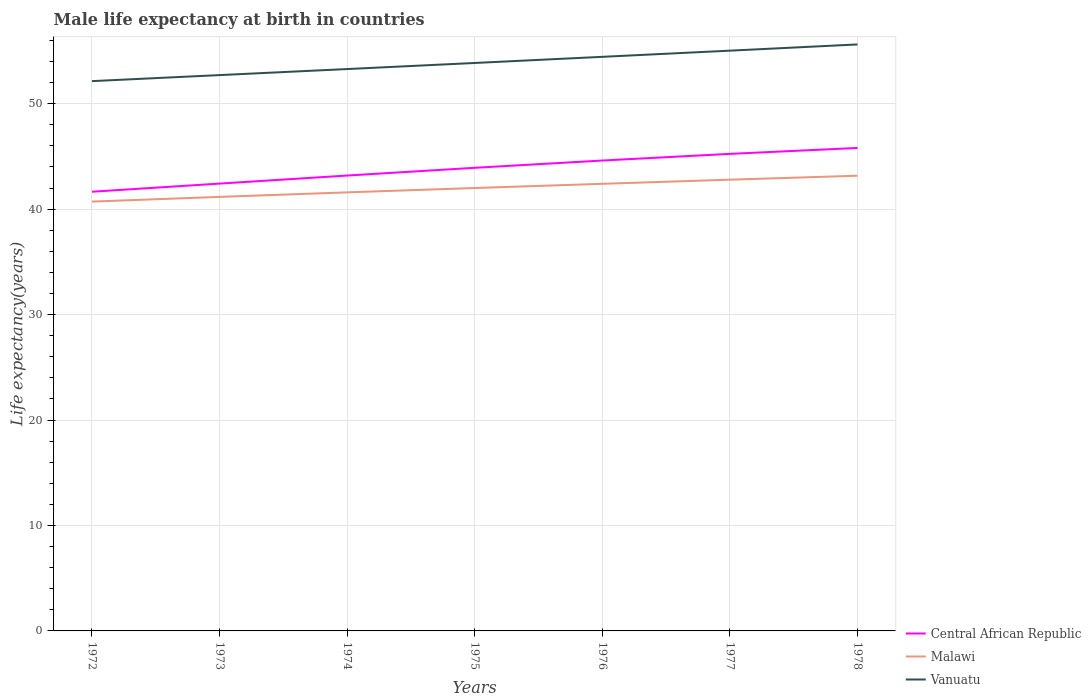How many different coloured lines are there?
Offer a very short reply. 3. Across all years, what is the maximum male life expectancy at birth in Central African Republic?
Offer a terse response. 41.65. What is the total male life expectancy at birth in Vanuatu in the graph?
Give a very brief answer. -0.58. What is the difference between the highest and the second highest male life expectancy at birth in Malawi?
Provide a succinct answer. 2.45. Is the male life expectancy at birth in Vanuatu strictly greater than the male life expectancy at birth in Central African Republic over the years?
Keep it short and to the point. No. How many lines are there?
Make the answer very short. 3. What is the difference between two consecutive major ticks on the Y-axis?
Give a very brief answer. 10. Are the values on the major ticks of Y-axis written in scientific E-notation?
Provide a short and direct response. No. Does the graph contain any zero values?
Your response must be concise. No. What is the title of the graph?
Offer a very short reply. Male life expectancy at birth in countries. Does "Morocco" appear as one of the legend labels in the graph?
Your response must be concise. No. What is the label or title of the Y-axis?
Ensure brevity in your answer.  Life expectancy(years). What is the Life expectancy(years) of Central African Republic in 1972?
Provide a short and direct response. 41.65. What is the Life expectancy(years) of Malawi in 1972?
Ensure brevity in your answer.  40.71. What is the Life expectancy(years) in Vanuatu in 1972?
Offer a very short reply. 52.14. What is the Life expectancy(years) of Central African Republic in 1973?
Give a very brief answer. 42.42. What is the Life expectancy(years) of Malawi in 1973?
Offer a terse response. 41.16. What is the Life expectancy(years) in Vanuatu in 1973?
Provide a succinct answer. 52.71. What is the Life expectancy(years) in Central African Republic in 1974?
Provide a succinct answer. 43.18. What is the Life expectancy(years) of Malawi in 1974?
Provide a succinct answer. 41.59. What is the Life expectancy(years) in Vanuatu in 1974?
Give a very brief answer. 53.28. What is the Life expectancy(years) in Central African Republic in 1975?
Provide a short and direct response. 43.92. What is the Life expectancy(years) in Malawi in 1975?
Your answer should be very brief. 42. What is the Life expectancy(years) in Vanuatu in 1975?
Provide a short and direct response. 53.86. What is the Life expectancy(years) in Central African Republic in 1976?
Provide a succinct answer. 44.61. What is the Life expectancy(years) in Malawi in 1976?
Provide a succinct answer. 42.4. What is the Life expectancy(years) in Vanuatu in 1976?
Provide a short and direct response. 54.44. What is the Life expectancy(years) in Central African Republic in 1977?
Keep it short and to the point. 45.24. What is the Life expectancy(years) of Malawi in 1977?
Offer a terse response. 42.79. What is the Life expectancy(years) of Vanuatu in 1977?
Make the answer very short. 55.03. What is the Life expectancy(years) of Central African Republic in 1978?
Give a very brief answer. 45.8. What is the Life expectancy(years) of Malawi in 1978?
Offer a terse response. 43.17. What is the Life expectancy(years) of Vanuatu in 1978?
Your answer should be very brief. 55.62. Across all years, what is the maximum Life expectancy(years) in Central African Republic?
Your answer should be compact. 45.8. Across all years, what is the maximum Life expectancy(years) in Malawi?
Your answer should be very brief. 43.17. Across all years, what is the maximum Life expectancy(years) of Vanuatu?
Your answer should be very brief. 55.62. Across all years, what is the minimum Life expectancy(years) of Central African Republic?
Your answer should be very brief. 41.65. Across all years, what is the minimum Life expectancy(years) of Malawi?
Offer a terse response. 40.71. Across all years, what is the minimum Life expectancy(years) in Vanuatu?
Your answer should be very brief. 52.14. What is the total Life expectancy(years) of Central African Republic in the graph?
Ensure brevity in your answer.  306.81. What is the total Life expectancy(years) in Malawi in the graph?
Provide a short and direct response. 293.82. What is the total Life expectancy(years) of Vanuatu in the graph?
Your answer should be very brief. 377.07. What is the difference between the Life expectancy(years) of Central African Republic in 1972 and that in 1973?
Keep it short and to the point. -0.77. What is the difference between the Life expectancy(years) in Malawi in 1972 and that in 1973?
Offer a terse response. -0.45. What is the difference between the Life expectancy(years) of Vanuatu in 1972 and that in 1973?
Provide a short and direct response. -0.57. What is the difference between the Life expectancy(years) in Central African Republic in 1972 and that in 1974?
Ensure brevity in your answer.  -1.53. What is the difference between the Life expectancy(years) of Malawi in 1972 and that in 1974?
Your answer should be compact. -0.88. What is the difference between the Life expectancy(years) of Vanuatu in 1972 and that in 1974?
Provide a succinct answer. -1.15. What is the difference between the Life expectancy(years) of Central African Republic in 1972 and that in 1975?
Ensure brevity in your answer.  -2.27. What is the difference between the Life expectancy(years) in Malawi in 1972 and that in 1975?
Provide a short and direct response. -1.29. What is the difference between the Life expectancy(years) of Vanuatu in 1972 and that in 1975?
Your response must be concise. -1.72. What is the difference between the Life expectancy(years) of Central African Republic in 1972 and that in 1976?
Offer a terse response. -2.96. What is the difference between the Life expectancy(years) of Malawi in 1972 and that in 1976?
Your answer should be very brief. -1.69. What is the difference between the Life expectancy(years) in Vanuatu in 1972 and that in 1976?
Make the answer very short. -2.3. What is the difference between the Life expectancy(years) in Central African Republic in 1972 and that in 1977?
Your answer should be compact. -3.59. What is the difference between the Life expectancy(years) of Malawi in 1972 and that in 1977?
Offer a terse response. -2.08. What is the difference between the Life expectancy(years) of Vanuatu in 1972 and that in 1977?
Make the answer very short. -2.89. What is the difference between the Life expectancy(years) of Central African Republic in 1972 and that in 1978?
Offer a very short reply. -4.15. What is the difference between the Life expectancy(years) of Malawi in 1972 and that in 1978?
Offer a very short reply. -2.45. What is the difference between the Life expectancy(years) in Vanuatu in 1972 and that in 1978?
Your response must be concise. -3.48. What is the difference between the Life expectancy(years) in Central African Republic in 1973 and that in 1974?
Make the answer very short. -0.76. What is the difference between the Life expectancy(years) in Malawi in 1973 and that in 1974?
Your answer should be very brief. -0.43. What is the difference between the Life expectancy(years) of Vanuatu in 1973 and that in 1974?
Offer a terse response. -0.57. What is the difference between the Life expectancy(years) of Central African Republic in 1973 and that in 1975?
Offer a very short reply. -1.5. What is the difference between the Life expectancy(years) of Malawi in 1973 and that in 1975?
Your answer should be compact. -0.84. What is the difference between the Life expectancy(years) in Vanuatu in 1973 and that in 1975?
Ensure brevity in your answer.  -1.15. What is the difference between the Life expectancy(years) of Central African Republic in 1973 and that in 1976?
Offer a terse response. -2.19. What is the difference between the Life expectancy(years) of Malawi in 1973 and that in 1976?
Keep it short and to the point. -1.24. What is the difference between the Life expectancy(years) of Vanuatu in 1973 and that in 1976?
Offer a terse response. -1.73. What is the difference between the Life expectancy(years) of Central African Republic in 1973 and that in 1977?
Provide a short and direct response. -2.82. What is the difference between the Life expectancy(years) in Malawi in 1973 and that in 1977?
Provide a short and direct response. -1.63. What is the difference between the Life expectancy(years) in Vanuatu in 1973 and that in 1977?
Your response must be concise. -2.32. What is the difference between the Life expectancy(years) of Central African Republic in 1973 and that in 1978?
Your answer should be very brief. -3.38. What is the difference between the Life expectancy(years) of Malawi in 1973 and that in 1978?
Keep it short and to the point. -2.01. What is the difference between the Life expectancy(years) in Vanuatu in 1973 and that in 1978?
Offer a very short reply. -2.91. What is the difference between the Life expectancy(years) in Central African Republic in 1974 and that in 1975?
Make the answer very short. -0.73. What is the difference between the Life expectancy(years) of Malawi in 1974 and that in 1975?
Your response must be concise. -0.41. What is the difference between the Life expectancy(years) of Vanuatu in 1974 and that in 1975?
Ensure brevity in your answer.  -0.58. What is the difference between the Life expectancy(years) of Central African Republic in 1974 and that in 1976?
Offer a very short reply. -1.42. What is the difference between the Life expectancy(years) of Malawi in 1974 and that in 1976?
Your answer should be compact. -0.81. What is the difference between the Life expectancy(years) of Vanuatu in 1974 and that in 1976?
Your answer should be very brief. -1.16. What is the difference between the Life expectancy(years) in Central African Republic in 1974 and that in 1977?
Give a very brief answer. -2.06. What is the difference between the Life expectancy(years) of Malawi in 1974 and that in 1977?
Provide a succinct answer. -1.2. What is the difference between the Life expectancy(years) in Vanuatu in 1974 and that in 1977?
Provide a succinct answer. -1.74. What is the difference between the Life expectancy(years) of Central African Republic in 1974 and that in 1978?
Make the answer very short. -2.62. What is the difference between the Life expectancy(years) in Malawi in 1974 and that in 1978?
Offer a terse response. -1.58. What is the difference between the Life expectancy(years) in Vanuatu in 1974 and that in 1978?
Offer a terse response. -2.33. What is the difference between the Life expectancy(years) in Central African Republic in 1975 and that in 1976?
Offer a very short reply. -0.69. What is the difference between the Life expectancy(years) of Malawi in 1975 and that in 1976?
Your response must be concise. -0.4. What is the difference between the Life expectancy(years) of Vanuatu in 1975 and that in 1976?
Offer a very short reply. -0.58. What is the difference between the Life expectancy(years) in Central African Republic in 1975 and that in 1977?
Provide a succinct answer. -1.32. What is the difference between the Life expectancy(years) in Malawi in 1975 and that in 1977?
Keep it short and to the point. -0.79. What is the difference between the Life expectancy(years) in Vanuatu in 1975 and that in 1977?
Your answer should be compact. -1.17. What is the difference between the Life expectancy(years) of Central African Republic in 1975 and that in 1978?
Provide a succinct answer. -1.88. What is the difference between the Life expectancy(years) in Malawi in 1975 and that in 1978?
Ensure brevity in your answer.  -1.17. What is the difference between the Life expectancy(years) of Vanuatu in 1975 and that in 1978?
Provide a succinct answer. -1.76. What is the difference between the Life expectancy(years) in Central African Republic in 1976 and that in 1977?
Provide a short and direct response. -0.63. What is the difference between the Life expectancy(years) in Malawi in 1976 and that in 1977?
Make the answer very short. -0.39. What is the difference between the Life expectancy(years) in Vanuatu in 1976 and that in 1977?
Offer a terse response. -0.59. What is the difference between the Life expectancy(years) of Central African Republic in 1976 and that in 1978?
Provide a short and direct response. -1.19. What is the difference between the Life expectancy(years) of Malawi in 1976 and that in 1978?
Offer a terse response. -0.77. What is the difference between the Life expectancy(years) of Vanuatu in 1976 and that in 1978?
Give a very brief answer. -1.18. What is the difference between the Life expectancy(years) of Central African Republic in 1977 and that in 1978?
Your answer should be very brief. -0.56. What is the difference between the Life expectancy(years) in Malawi in 1977 and that in 1978?
Provide a short and direct response. -0.38. What is the difference between the Life expectancy(years) in Vanuatu in 1977 and that in 1978?
Keep it short and to the point. -0.59. What is the difference between the Life expectancy(years) of Central African Republic in 1972 and the Life expectancy(years) of Malawi in 1973?
Ensure brevity in your answer.  0.49. What is the difference between the Life expectancy(years) in Central African Republic in 1972 and the Life expectancy(years) in Vanuatu in 1973?
Make the answer very short. -11.06. What is the difference between the Life expectancy(years) in Malawi in 1972 and the Life expectancy(years) in Vanuatu in 1973?
Your answer should be compact. -12. What is the difference between the Life expectancy(years) in Central African Republic in 1972 and the Life expectancy(years) in Vanuatu in 1974?
Provide a succinct answer. -11.63. What is the difference between the Life expectancy(years) in Malawi in 1972 and the Life expectancy(years) in Vanuatu in 1974?
Ensure brevity in your answer.  -12.57. What is the difference between the Life expectancy(years) in Central African Republic in 1972 and the Life expectancy(years) in Malawi in 1975?
Your response must be concise. -0.35. What is the difference between the Life expectancy(years) in Central African Republic in 1972 and the Life expectancy(years) in Vanuatu in 1975?
Provide a short and direct response. -12.21. What is the difference between the Life expectancy(years) in Malawi in 1972 and the Life expectancy(years) in Vanuatu in 1975?
Your response must be concise. -13.14. What is the difference between the Life expectancy(years) of Central African Republic in 1972 and the Life expectancy(years) of Malawi in 1976?
Make the answer very short. -0.75. What is the difference between the Life expectancy(years) of Central African Republic in 1972 and the Life expectancy(years) of Vanuatu in 1976?
Make the answer very short. -12.79. What is the difference between the Life expectancy(years) of Malawi in 1972 and the Life expectancy(years) of Vanuatu in 1976?
Your answer should be compact. -13.73. What is the difference between the Life expectancy(years) of Central African Republic in 1972 and the Life expectancy(years) of Malawi in 1977?
Provide a short and direct response. -1.14. What is the difference between the Life expectancy(years) in Central African Republic in 1972 and the Life expectancy(years) in Vanuatu in 1977?
Your response must be concise. -13.38. What is the difference between the Life expectancy(years) of Malawi in 1972 and the Life expectancy(years) of Vanuatu in 1977?
Ensure brevity in your answer.  -14.31. What is the difference between the Life expectancy(years) in Central African Republic in 1972 and the Life expectancy(years) in Malawi in 1978?
Your response must be concise. -1.52. What is the difference between the Life expectancy(years) in Central African Republic in 1972 and the Life expectancy(years) in Vanuatu in 1978?
Your answer should be compact. -13.97. What is the difference between the Life expectancy(years) in Malawi in 1972 and the Life expectancy(years) in Vanuatu in 1978?
Offer a very short reply. -14.9. What is the difference between the Life expectancy(years) in Central African Republic in 1973 and the Life expectancy(years) in Malawi in 1974?
Give a very brief answer. 0.83. What is the difference between the Life expectancy(years) of Central African Republic in 1973 and the Life expectancy(years) of Vanuatu in 1974?
Offer a very short reply. -10.86. What is the difference between the Life expectancy(years) in Malawi in 1973 and the Life expectancy(years) in Vanuatu in 1974?
Offer a very short reply. -12.12. What is the difference between the Life expectancy(years) of Central African Republic in 1973 and the Life expectancy(years) of Malawi in 1975?
Offer a terse response. 0.42. What is the difference between the Life expectancy(years) of Central African Republic in 1973 and the Life expectancy(years) of Vanuatu in 1975?
Make the answer very short. -11.44. What is the difference between the Life expectancy(years) of Malawi in 1973 and the Life expectancy(years) of Vanuatu in 1975?
Offer a very short reply. -12.7. What is the difference between the Life expectancy(years) in Central African Republic in 1973 and the Life expectancy(years) in Malawi in 1976?
Provide a succinct answer. 0.02. What is the difference between the Life expectancy(years) of Central African Republic in 1973 and the Life expectancy(years) of Vanuatu in 1976?
Provide a succinct answer. -12.02. What is the difference between the Life expectancy(years) of Malawi in 1973 and the Life expectancy(years) of Vanuatu in 1976?
Ensure brevity in your answer.  -13.28. What is the difference between the Life expectancy(years) in Central African Republic in 1973 and the Life expectancy(years) in Malawi in 1977?
Provide a succinct answer. -0.37. What is the difference between the Life expectancy(years) of Central African Republic in 1973 and the Life expectancy(years) of Vanuatu in 1977?
Offer a very short reply. -12.61. What is the difference between the Life expectancy(years) of Malawi in 1973 and the Life expectancy(years) of Vanuatu in 1977?
Keep it short and to the point. -13.87. What is the difference between the Life expectancy(years) of Central African Republic in 1973 and the Life expectancy(years) of Malawi in 1978?
Keep it short and to the point. -0.75. What is the difference between the Life expectancy(years) in Central African Republic in 1973 and the Life expectancy(years) in Vanuatu in 1978?
Your answer should be compact. -13.2. What is the difference between the Life expectancy(years) of Malawi in 1973 and the Life expectancy(years) of Vanuatu in 1978?
Your answer should be very brief. -14.46. What is the difference between the Life expectancy(years) in Central African Republic in 1974 and the Life expectancy(years) in Malawi in 1975?
Your response must be concise. 1.18. What is the difference between the Life expectancy(years) of Central African Republic in 1974 and the Life expectancy(years) of Vanuatu in 1975?
Give a very brief answer. -10.68. What is the difference between the Life expectancy(years) in Malawi in 1974 and the Life expectancy(years) in Vanuatu in 1975?
Ensure brevity in your answer.  -12.27. What is the difference between the Life expectancy(years) in Central African Republic in 1974 and the Life expectancy(years) in Malawi in 1976?
Offer a very short reply. 0.78. What is the difference between the Life expectancy(years) of Central African Republic in 1974 and the Life expectancy(years) of Vanuatu in 1976?
Your response must be concise. -11.26. What is the difference between the Life expectancy(years) in Malawi in 1974 and the Life expectancy(years) in Vanuatu in 1976?
Provide a short and direct response. -12.85. What is the difference between the Life expectancy(years) in Central African Republic in 1974 and the Life expectancy(years) in Malawi in 1977?
Make the answer very short. 0.39. What is the difference between the Life expectancy(years) in Central African Republic in 1974 and the Life expectancy(years) in Vanuatu in 1977?
Make the answer very short. -11.84. What is the difference between the Life expectancy(years) in Malawi in 1974 and the Life expectancy(years) in Vanuatu in 1977?
Your response must be concise. -13.44. What is the difference between the Life expectancy(years) in Central African Republic in 1974 and the Life expectancy(years) in Malawi in 1978?
Make the answer very short. 0.01. What is the difference between the Life expectancy(years) in Central African Republic in 1974 and the Life expectancy(years) in Vanuatu in 1978?
Offer a very short reply. -12.43. What is the difference between the Life expectancy(years) of Malawi in 1974 and the Life expectancy(years) of Vanuatu in 1978?
Provide a succinct answer. -14.03. What is the difference between the Life expectancy(years) in Central African Republic in 1975 and the Life expectancy(years) in Malawi in 1976?
Keep it short and to the point. 1.52. What is the difference between the Life expectancy(years) of Central African Republic in 1975 and the Life expectancy(years) of Vanuatu in 1976?
Offer a terse response. -10.52. What is the difference between the Life expectancy(years) of Malawi in 1975 and the Life expectancy(years) of Vanuatu in 1976?
Offer a very short reply. -12.44. What is the difference between the Life expectancy(years) of Central African Republic in 1975 and the Life expectancy(years) of Malawi in 1977?
Offer a terse response. 1.13. What is the difference between the Life expectancy(years) in Central African Republic in 1975 and the Life expectancy(years) in Vanuatu in 1977?
Your answer should be compact. -11.11. What is the difference between the Life expectancy(years) of Malawi in 1975 and the Life expectancy(years) of Vanuatu in 1977?
Give a very brief answer. -13.03. What is the difference between the Life expectancy(years) of Central African Republic in 1975 and the Life expectancy(years) of Vanuatu in 1978?
Offer a very short reply. -11.7. What is the difference between the Life expectancy(years) in Malawi in 1975 and the Life expectancy(years) in Vanuatu in 1978?
Offer a very short reply. -13.62. What is the difference between the Life expectancy(years) in Central African Republic in 1976 and the Life expectancy(years) in Malawi in 1977?
Your answer should be compact. 1.82. What is the difference between the Life expectancy(years) in Central African Republic in 1976 and the Life expectancy(years) in Vanuatu in 1977?
Provide a short and direct response. -10.42. What is the difference between the Life expectancy(years) in Malawi in 1976 and the Life expectancy(years) in Vanuatu in 1977?
Your answer should be compact. -12.63. What is the difference between the Life expectancy(years) of Central African Republic in 1976 and the Life expectancy(years) of Malawi in 1978?
Offer a very short reply. 1.44. What is the difference between the Life expectancy(years) of Central African Republic in 1976 and the Life expectancy(years) of Vanuatu in 1978?
Provide a succinct answer. -11.01. What is the difference between the Life expectancy(years) in Malawi in 1976 and the Life expectancy(years) in Vanuatu in 1978?
Your answer should be very brief. -13.22. What is the difference between the Life expectancy(years) of Central African Republic in 1977 and the Life expectancy(years) of Malawi in 1978?
Your response must be concise. 2.07. What is the difference between the Life expectancy(years) in Central African Republic in 1977 and the Life expectancy(years) in Vanuatu in 1978?
Keep it short and to the point. -10.38. What is the difference between the Life expectancy(years) in Malawi in 1977 and the Life expectancy(years) in Vanuatu in 1978?
Offer a terse response. -12.83. What is the average Life expectancy(years) in Central African Republic per year?
Give a very brief answer. 43.83. What is the average Life expectancy(years) of Malawi per year?
Make the answer very short. 41.97. What is the average Life expectancy(years) of Vanuatu per year?
Provide a short and direct response. 53.87. In the year 1972, what is the difference between the Life expectancy(years) of Central African Republic and Life expectancy(years) of Malawi?
Give a very brief answer. 0.94. In the year 1972, what is the difference between the Life expectancy(years) of Central African Republic and Life expectancy(years) of Vanuatu?
Provide a short and direct response. -10.49. In the year 1972, what is the difference between the Life expectancy(years) in Malawi and Life expectancy(years) in Vanuatu?
Provide a short and direct response. -11.42. In the year 1973, what is the difference between the Life expectancy(years) in Central African Republic and Life expectancy(years) in Malawi?
Give a very brief answer. 1.26. In the year 1973, what is the difference between the Life expectancy(years) in Central African Republic and Life expectancy(years) in Vanuatu?
Provide a short and direct response. -10.29. In the year 1973, what is the difference between the Life expectancy(years) in Malawi and Life expectancy(years) in Vanuatu?
Keep it short and to the point. -11.55. In the year 1974, what is the difference between the Life expectancy(years) in Central African Republic and Life expectancy(years) in Malawi?
Provide a short and direct response. 1.59. In the year 1974, what is the difference between the Life expectancy(years) in Malawi and Life expectancy(years) in Vanuatu?
Offer a very short reply. -11.69. In the year 1975, what is the difference between the Life expectancy(years) in Central African Republic and Life expectancy(years) in Malawi?
Give a very brief answer. 1.92. In the year 1975, what is the difference between the Life expectancy(years) in Central African Republic and Life expectancy(years) in Vanuatu?
Give a very brief answer. -9.94. In the year 1975, what is the difference between the Life expectancy(years) of Malawi and Life expectancy(years) of Vanuatu?
Your answer should be very brief. -11.86. In the year 1976, what is the difference between the Life expectancy(years) of Central African Republic and Life expectancy(years) of Malawi?
Your answer should be compact. 2.21. In the year 1976, what is the difference between the Life expectancy(years) of Central African Republic and Life expectancy(years) of Vanuatu?
Your answer should be very brief. -9.83. In the year 1976, what is the difference between the Life expectancy(years) of Malawi and Life expectancy(years) of Vanuatu?
Your response must be concise. -12.04. In the year 1977, what is the difference between the Life expectancy(years) in Central African Republic and Life expectancy(years) in Malawi?
Make the answer very short. 2.45. In the year 1977, what is the difference between the Life expectancy(years) of Central African Republic and Life expectancy(years) of Vanuatu?
Provide a short and direct response. -9.79. In the year 1977, what is the difference between the Life expectancy(years) of Malawi and Life expectancy(years) of Vanuatu?
Your answer should be very brief. -12.24. In the year 1978, what is the difference between the Life expectancy(years) of Central African Republic and Life expectancy(years) of Malawi?
Your answer should be compact. 2.63. In the year 1978, what is the difference between the Life expectancy(years) of Central African Republic and Life expectancy(years) of Vanuatu?
Your answer should be compact. -9.82. In the year 1978, what is the difference between the Life expectancy(years) in Malawi and Life expectancy(years) in Vanuatu?
Offer a terse response. -12.45. What is the ratio of the Life expectancy(years) of Central African Republic in 1972 to that in 1973?
Offer a very short reply. 0.98. What is the ratio of the Life expectancy(years) of Vanuatu in 1972 to that in 1973?
Provide a succinct answer. 0.99. What is the ratio of the Life expectancy(years) of Central African Republic in 1972 to that in 1974?
Give a very brief answer. 0.96. What is the ratio of the Life expectancy(years) in Malawi in 1972 to that in 1974?
Keep it short and to the point. 0.98. What is the ratio of the Life expectancy(years) of Vanuatu in 1972 to that in 1974?
Give a very brief answer. 0.98. What is the ratio of the Life expectancy(years) of Central African Republic in 1972 to that in 1975?
Ensure brevity in your answer.  0.95. What is the ratio of the Life expectancy(years) of Malawi in 1972 to that in 1975?
Ensure brevity in your answer.  0.97. What is the ratio of the Life expectancy(years) of Vanuatu in 1972 to that in 1975?
Provide a short and direct response. 0.97. What is the ratio of the Life expectancy(years) in Central African Republic in 1972 to that in 1976?
Make the answer very short. 0.93. What is the ratio of the Life expectancy(years) in Malawi in 1972 to that in 1976?
Ensure brevity in your answer.  0.96. What is the ratio of the Life expectancy(years) of Vanuatu in 1972 to that in 1976?
Make the answer very short. 0.96. What is the ratio of the Life expectancy(years) in Central African Republic in 1972 to that in 1977?
Give a very brief answer. 0.92. What is the ratio of the Life expectancy(years) of Malawi in 1972 to that in 1977?
Offer a terse response. 0.95. What is the ratio of the Life expectancy(years) of Vanuatu in 1972 to that in 1977?
Your answer should be compact. 0.95. What is the ratio of the Life expectancy(years) of Central African Republic in 1972 to that in 1978?
Your answer should be very brief. 0.91. What is the ratio of the Life expectancy(years) of Malawi in 1972 to that in 1978?
Ensure brevity in your answer.  0.94. What is the ratio of the Life expectancy(years) in Vanuatu in 1972 to that in 1978?
Your answer should be compact. 0.94. What is the ratio of the Life expectancy(years) of Central African Republic in 1973 to that in 1974?
Your answer should be compact. 0.98. What is the ratio of the Life expectancy(years) in Malawi in 1973 to that in 1974?
Your answer should be compact. 0.99. What is the ratio of the Life expectancy(years) of Central African Republic in 1973 to that in 1975?
Keep it short and to the point. 0.97. What is the ratio of the Life expectancy(years) of Malawi in 1973 to that in 1975?
Your answer should be compact. 0.98. What is the ratio of the Life expectancy(years) in Vanuatu in 1973 to that in 1975?
Make the answer very short. 0.98. What is the ratio of the Life expectancy(years) of Central African Republic in 1973 to that in 1976?
Your answer should be very brief. 0.95. What is the ratio of the Life expectancy(years) in Malawi in 1973 to that in 1976?
Offer a very short reply. 0.97. What is the ratio of the Life expectancy(years) of Vanuatu in 1973 to that in 1976?
Keep it short and to the point. 0.97. What is the ratio of the Life expectancy(years) of Central African Republic in 1973 to that in 1977?
Offer a terse response. 0.94. What is the ratio of the Life expectancy(years) in Malawi in 1973 to that in 1977?
Make the answer very short. 0.96. What is the ratio of the Life expectancy(years) of Vanuatu in 1973 to that in 1977?
Provide a succinct answer. 0.96. What is the ratio of the Life expectancy(years) of Central African Republic in 1973 to that in 1978?
Keep it short and to the point. 0.93. What is the ratio of the Life expectancy(years) of Malawi in 1973 to that in 1978?
Provide a short and direct response. 0.95. What is the ratio of the Life expectancy(years) in Vanuatu in 1973 to that in 1978?
Provide a short and direct response. 0.95. What is the ratio of the Life expectancy(years) of Central African Republic in 1974 to that in 1975?
Ensure brevity in your answer.  0.98. What is the ratio of the Life expectancy(years) in Malawi in 1974 to that in 1975?
Keep it short and to the point. 0.99. What is the ratio of the Life expectancy(years) of Vanuatu in 1974 to that in 1975?
Your answer should be very brief. 0.99. What is the ratio of the Life expectancy(years) in Central African Republic in 1974 to that in 1976?
Ensure brevity in your answer.  0.97. What is the ratio of the Life expectancy(years) of Malawi in 1974 to that in 1976?
Offer a very short reply. 0.98. What is the ratio of the Life expectancy(years) of Vanuatu in 1974 to that in 1976?
Make the answer very short. 0.98. What is the ratio of the Life expectancy(years) in Central African Republic in 1974 to that in 1977?
Offer a very short reply. 0.95. What is the ratio of the Life expectancy(years) in Malawi in 1974 to that in 1977?
Your answer should be compact. 0.97. What is the ratio of the Life expectancy(years) in Vanuatu in 1974 to that in 1977?
Keep it short and to the point. 0.97. What is the ratio of the Life expectancy(years) in Central African Republic in 1974 to that in 1978?
Provide a short and direct response. 0.94. What is the ratio of the Life expectancy(years) in Malawi in 1974 to that in 1978?
Make the answer very short. 0.96. What is the ratio of the Life expectancy(years) of Vanuatu in 1974 to that in 1978?
Give a very brief answer. 0.96. What is the ratio of the Life expectancy(years) in Central African Republic in 1975 to that in 1976?
Offer a very short reply. 0.98. What is the ratio of the Life expectancy(years) in Malawi in 1975 to that in 1976?
Your answer should be very brief. 0.99. What is the ratio of the Life expectancy(years) in Vanuatu in 1975 to that in 1976?
Provide a short and direct response. 0.99. What is the ratio of the Life expectancy(years) in Central African Republic in 1975 to that in 1977?
Your response must be concise. 0.97. What is the ratio of the Life expectancy(years) in Malawi in 1975 to that in 1977?
Provide a succinct answer. 0.98. What is the ratio of the Life expectancy(years) in Vanuatu in 1975 to that in 1977?
Provide a succinct answer. 0.98. What is the ratio of the Life expectancy(years) in Central African Republic in 1975 to that in 1978?
Offer a terse response. 0.96. What is the ratio of the Life expectancy(years) in Vanuatu in 1975 to that in 1978?
Your answer should be very brief. 0.97. What is the ratio of the Life expectancy(years) of Central African Republic in 1976 to that in 1977?
Your response must be concise. 0.99. What is the ratio of the Life expectancy(years) in Malawi in 1976 to that in 1977?
Offer a terse response. 0.99. What is the ratio of the Life expectancy(years) in Malawi in 1976 to that in 1978?
Your response must be concise. 0.98. What is the ratio of the Life expectancy(years) in Vanuatu in 1976 to that in 1978?
Make the answer very short. 0.98. What is the ratio of the Life expectancy(years) in Central African Republic in 1977 to that in 1978?
Your answer should be very brief. 0.99. What is the difference between the highest and the second highest Life expectancy(years) of Central African Republic?
Make the answer very short. 0.56. What is the difference between the highest and the second highest Life expectancy(years) in Malawi?
Offer a very short reply. 0.38. What is the difference between the highest and the second highest Life expectancy(years) of Vanuatu?
Give a very brief answer. 0.59. What is the difference between the highest and the lowest Life expectancy(years) in Central African Republic?
Keep it short and to the point. 4.15. What is the difference between the highest and the lowest Life expectancy(years) of Malawi?
Ensure brevity in your answer.  2.45. What is the difference between the highest and the lowest Life expectancy(years) in Vanuatu?
Your answer should be very brief. 3.48. 